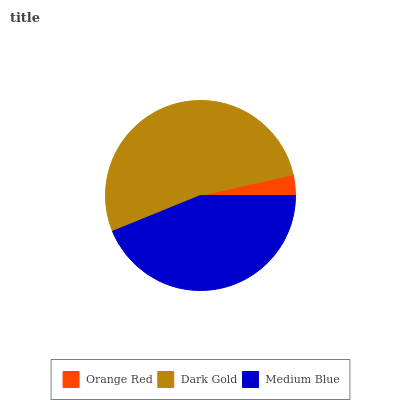Is Orange Red the minimum?
Answer yes or no. Yes. Is Dark Gold the maximum?
Answer yes or no. Yes. Is Medium Blue the minimum?
Answer yes or no. No. Is Medium Blue the maximum?
Answer yes or no. No. Is Dark Gold greater than Medium Blue?
Answer yes or no. Yes. Is Medium Blue less than Dark Gold?
Answer yes or no. Yes. Is Medium Blue greater than Dark Gold?
Answer yes or no. No. Is Dark Gold less than Medium Blue?
Answer yes or no. No. Is Medium Blue the high median?
Answer yes or no. Yes. Is Medium Blue the low median?
Answer yes or no. Yes. Is Dark Gold the high median?
Answer yes or no. No. Is Orange Red the low median?
Answer yes or no. No. 